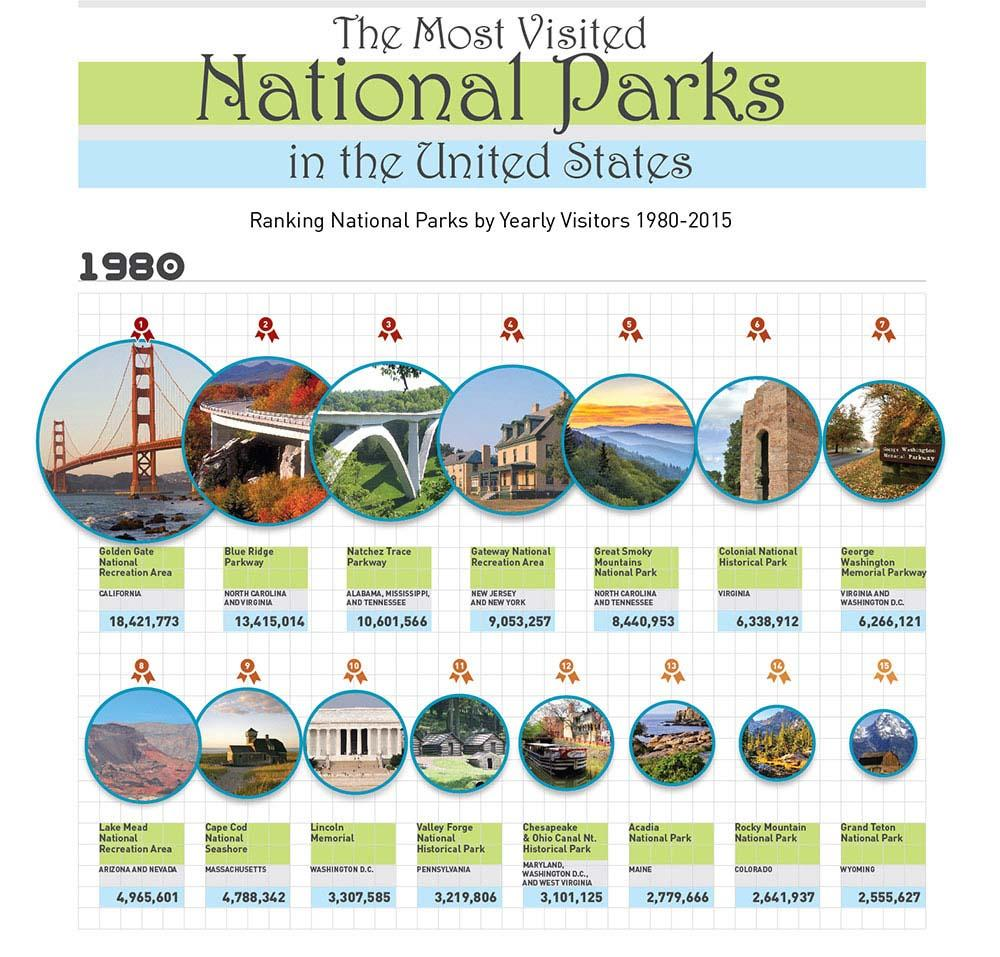List a handful of essential elements in this visual. In 1980, the Blue Ridge Parkway was ranked as the second most popular national park in the United States. Golden Gate National Recreation Area is located in the state of California. Valley Forge National Historical Park is located in the state of Pennsylvania. In 1980, Grand Teton National Park was ranked 15 among all national parks in the United States. Colonial National Historical Park is located in the state of Virginia. 